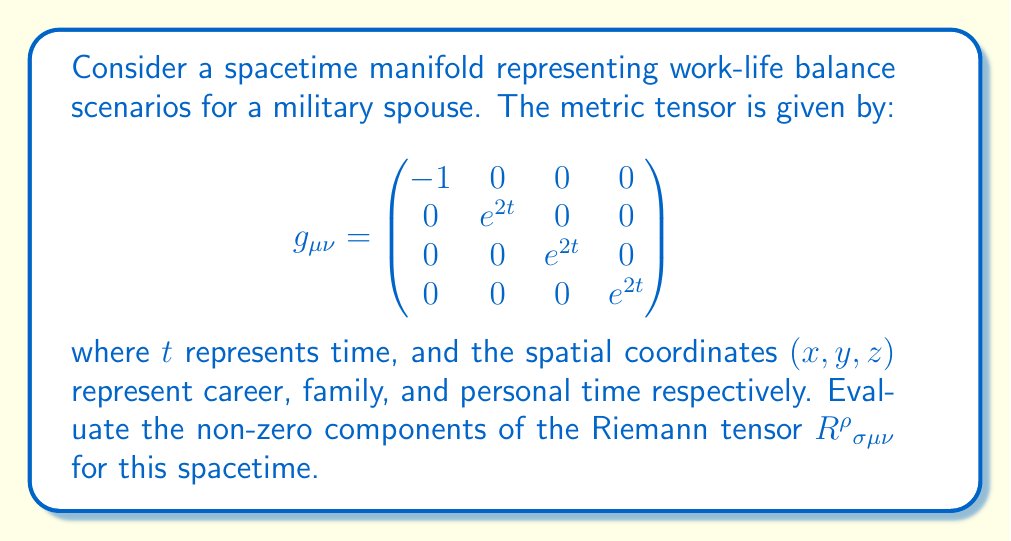Can you solve this math problem? To evaluate the Riemann tensor, we'll follow these steps:

1) First, we need to calculate the Christoffel symbols $\Gamma^\rho_{\mu\nu}$ using the metric tensor:

   $$\Gamma^\rho_{\mu\nu} = \frac{1}{2}g^{\rho\lambda}(\partial_\mu g_{\lambda\nu} + \partial_\nu g_{\lambda\mu} - \partial_\lambda g_{\mu\nu})$$

2) The non-zero Christoffel symbols are:

   $$\Gamma^i_{0i} = \Gamma^i_{i0} = 1 \quad \text{for } i = 1,2,3$$

3) Now, we can calculate the Riemann tensor using the formula:

   $$R^\rho{}_{\sigma\mu\nu} = \partial_\mu \Gamma^\rho_{\nu\sigma} - \partial_\nu \Gamma^\rho_{\mu\sigma} + \Gamma^\rho_{\mu\lambda}\Gamma^\lambda_{\nu\sigma} - \Gamma^\rho_{\nu\lambda}\Gamma^\lambda_{\mu\sigma}$$

4) The non-zero components are:

   $$R^i{}_{0i0} = -R^i{}_{00i} = e^{2t} \quad \text{for } i = 1,2,3$$

5) These components represent the curvature of spacetime in the work-life balance scenario. They indicate how the spatial dimensions (career, family, personal time) are affected by the passage of time in this model.

6) The physical interpretation in the context of work-life balance for a military spouse is that as time progresses (t increases), the curvature of spacetime increases exponentially in all spatial dimensions. This could represent the increasing complexity and challenges in balancing career, family, and personal time as a military spouse's career progresses.
Answer: $R^i{}_{0i0} = -R^i{}_{00i} = e^{2t}$ for $i = 1,2,3$ 